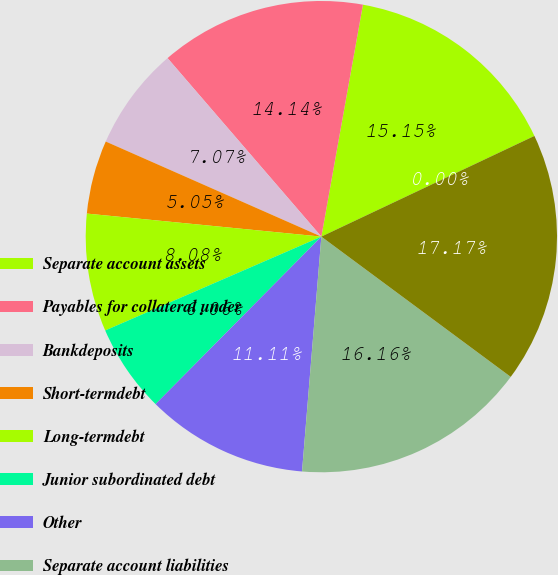Convert chart. <chart><loc_0><loc_0><loc_500><loc_500><pie_chart><fcel>Separate account assets<fcel>Payables for collateral under<fcel>Bankdeposits<fcel>Short-termdebt<fcel>Long-termdebt<fcel>Junior subordinated debt<fcel>Other<fcel>Separate account liabilities<fcel>Total liabilities<fcel>Preferredstockatparvalue<nl><fcel>15.15%<fcel>14.14%<fcel>7.07%<fcel>5.05%<fcel>8.08%<fcel>6.06%<fcel>11.11%<fcel>16.16%<fcel>17.17%<fcel>0.0%<nl></chart> 